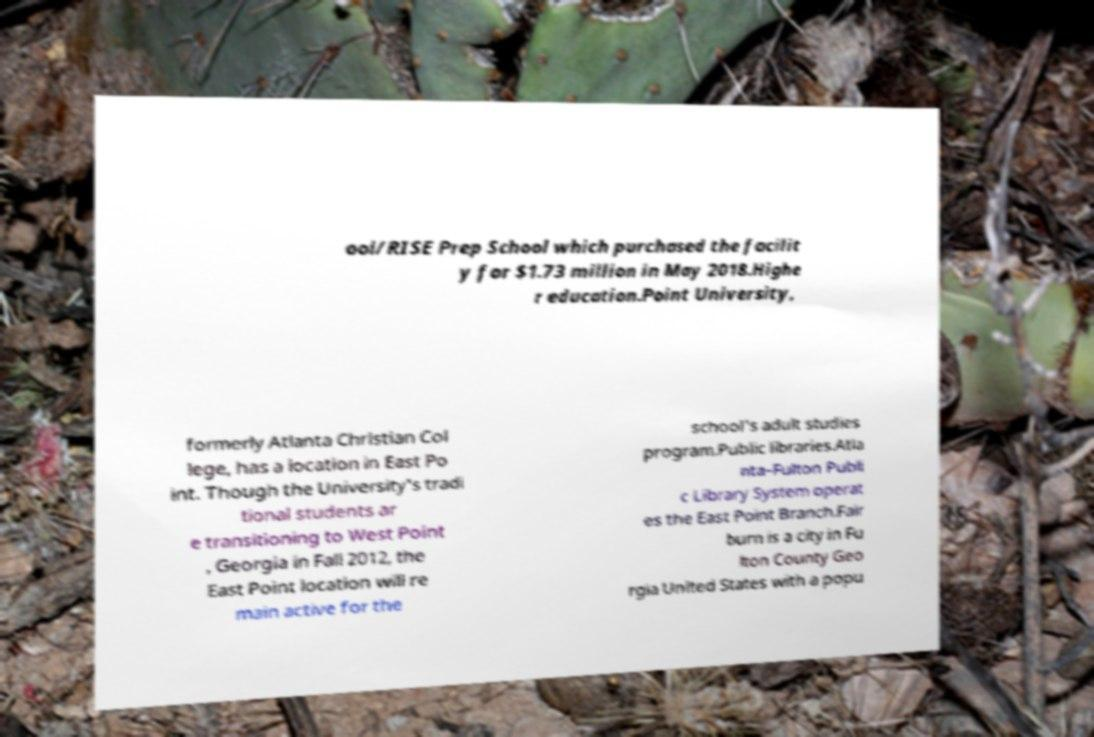For documentation purposes, I need the text within this image transcribed. Could you provide that? ool/RISE Prep School which purchased the facilit y for $1.73 million in May 2018.Highe r education.Point University, formerly Atlanta Christian Col lege, has a location in East Po int. Though the University's tradi tional students ar e transitioning to West Point , Georgia in Fall 2012, the East Point location will re main active for the school's adult studies program.Public libraries.Atla nta–Fulton Publi c Library System operat es the East Point Branch.Fair burn is a city in Fu lton County Geo rgia United States with a popu 